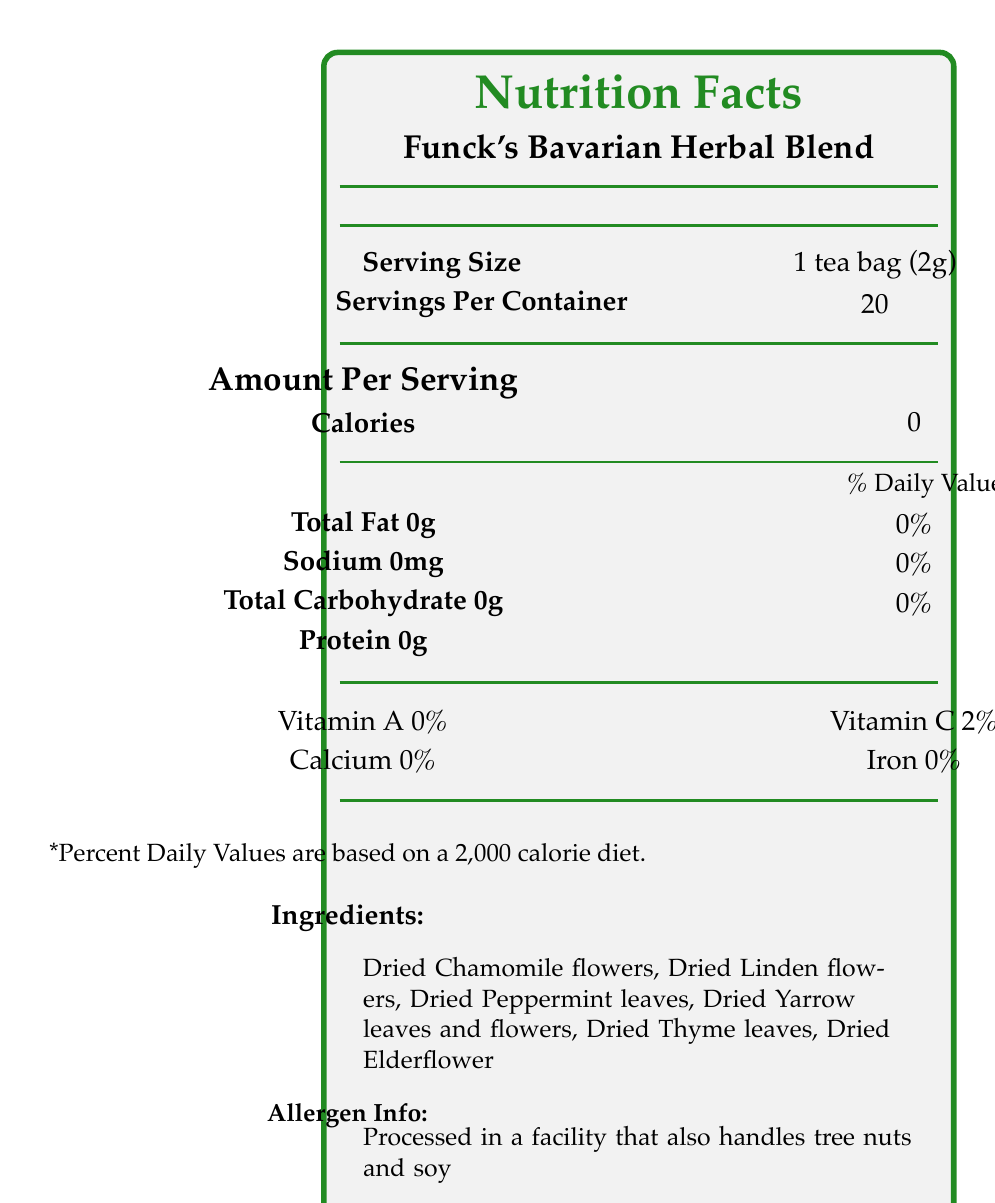what is the serving size? The serving size specified in the document is "1 tea bag (2g)".
Answer: 1 tea bag (2g) how many servings per container? The box indicates that there are 20 servings per container.
Answer: 20 how many calories are in a serving? The document shows that there are 0 calories per serving.
Answer: 0 what is the amount of vitamin C per serving? The document specifies that the vitamin C content is 2% of the daily value per serving.
Answer: 2% what facility is the tea processed in? According to the allergen information, the tea is processed in a facility that also handles tree nuts and soy.
Answer: Processed in a facility that also handles tree nuts and soy what are the main ingredients of Funck's Bavarian Herbal Blend? A. Chamomile, Rooibos, Peppermint B. Chamomile, Linden, Elderflower C. Green Tea, Chamomile, Thyme The ingredients listed are Dried Chamomile flowers, Dried Linden flowers, Dried Peppermint leaves, Dried Yarrow leaves and flowers, Dried Thyme leaves, and Dried Elderflower.
Answer: B. Chamomile, Linden, Elderflower what percentage of daily value does total fat represent in a serving? A. 0% B. 2% C. 5% D. 10% The document indicates that the amount of Total Fat is 0g, which is 0% of the daily value.
Answer: A. 0% is the herbal blend organic? The certifications include "Organic," confirming that the product is organic.
Answer: Yes where are the ingredients sourced from? The origin section denotes that the ingredients are sourced from the Bavarian Forest National Park.
Answer: The Bavarian Forest National Park what additional health benefits does the herbal blend claim to provide? Additional information states that it supports digestive health and relaxation.
Answer: Supports digestive health and relaxation who is the manufacturer of the herbal blend? The manufacturer listed is University of Erlangen-Nuremberg Botanical Gardens.
Answer: University of Erlangen-Nuremberg Botanical Gardens how long should the tea be steeped in hot water? The preparation section suggests steeping the tea in hot water (80°C) for 5-7 minutes.
Answer: 5-7 minutes is there any sodium in the herbal blend? The document lists the amount of sodium as 0mg, indicating no sodium content.
Answer: No describe what you see in the document. This covers all major aspects and sections of the document without going into excessive detail.
Answer: The document is a Nutrition Facts label for Funck's Bavarian Herbal Blend. It provides information on serving size (1 tea bag, 2g), number of servings per container (20), and nutritional content per serving (0 calories, 0g fat, 0mg sodium, 0g carbohydrate, 0g protein, 0% vitamin A, 2% vitamin C, 0% calcium, 0% iron). The ingredients include Dried Chamomile flowers, Linden flowers, Peppermint leaves, Yarrow leaves and flowers, Thyme leaves, and Elderflower. The allergen information states the product is processed in a facility that handles tree nuts and soy. Additionally, it mentions that the ingredients are sourced from the Bavarian Forest National Park and provides preparation and storage instructions. The product is certified organic and Non-GMO Project Verified. It is inspired by the work of Heinrich Christian Funck and claims to support digestive health and relaxation. Finally, the manufacturer and distributor details are provided along with the website and expiration information. which botanical element inspires the herbal blend? The botanical work of Heinrich Christian Funck is mentioned as the inspiration for the blend.
Answer: Heinrich Christian Funck is there any information about the possible existence of caffeine in the product? The document does not provide any information regarding the caffeine content of the herbal blend.
Answer: Not enough information how many certifications does the product have? The document lists two certifications: "Organic" and "Non-GMO Project Verified".
Answer: Two 